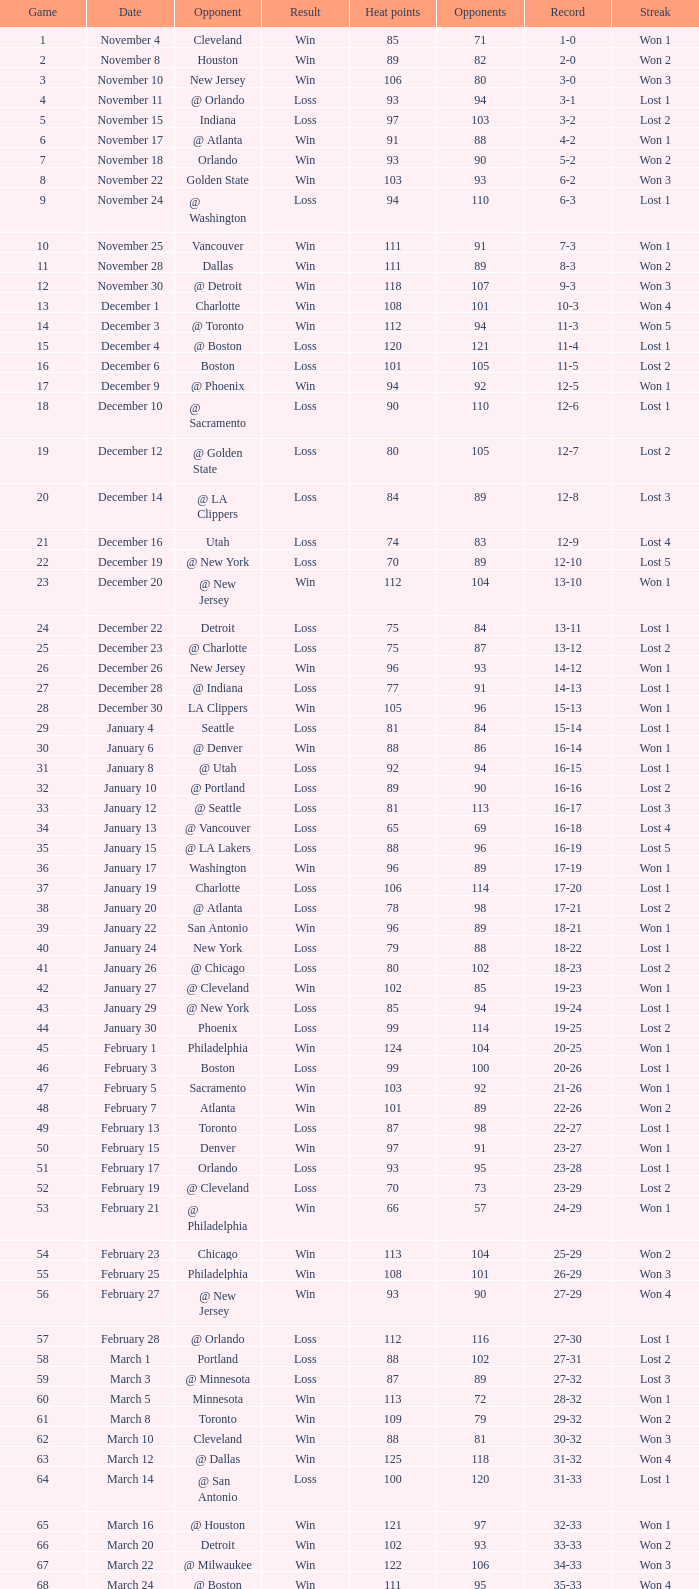What is Result, when Date is "December 12"? Loss. 